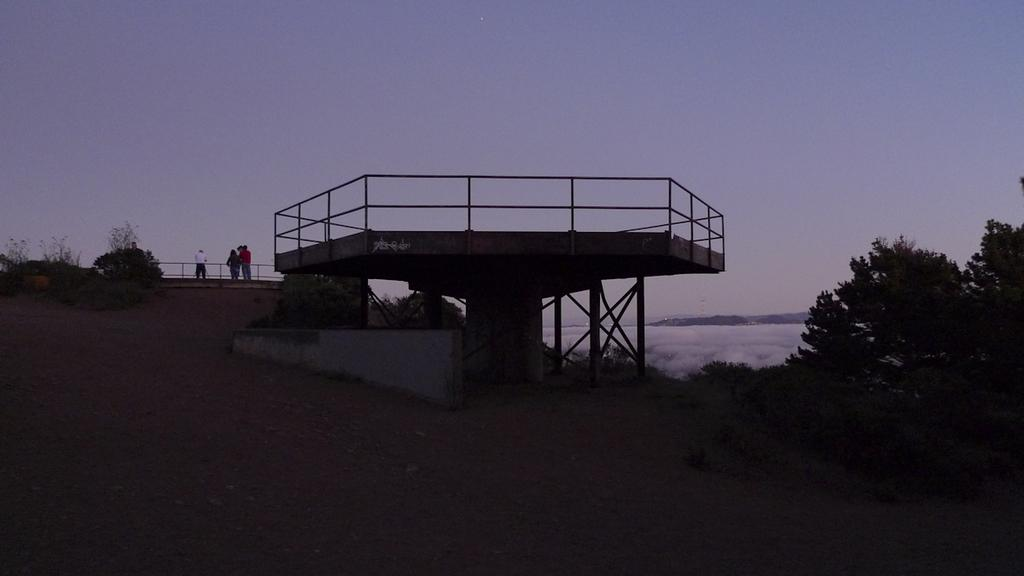What are the people in the image doing? The people in the image are standing on the ground. What type of natural elements can be seen in the image? Trees are visible in the image. What is located in the background of the image? There is a fence and the sky visible in the background of the image. How would you describe the lighting in the image? The image appears to be slightly dark. What type of garden can be seen in the image? There is no garden present in the image. How many hands are visible in the image? There is no mention of hands in the provided facts, so it cannot be determined how many hands are visible in the image. 